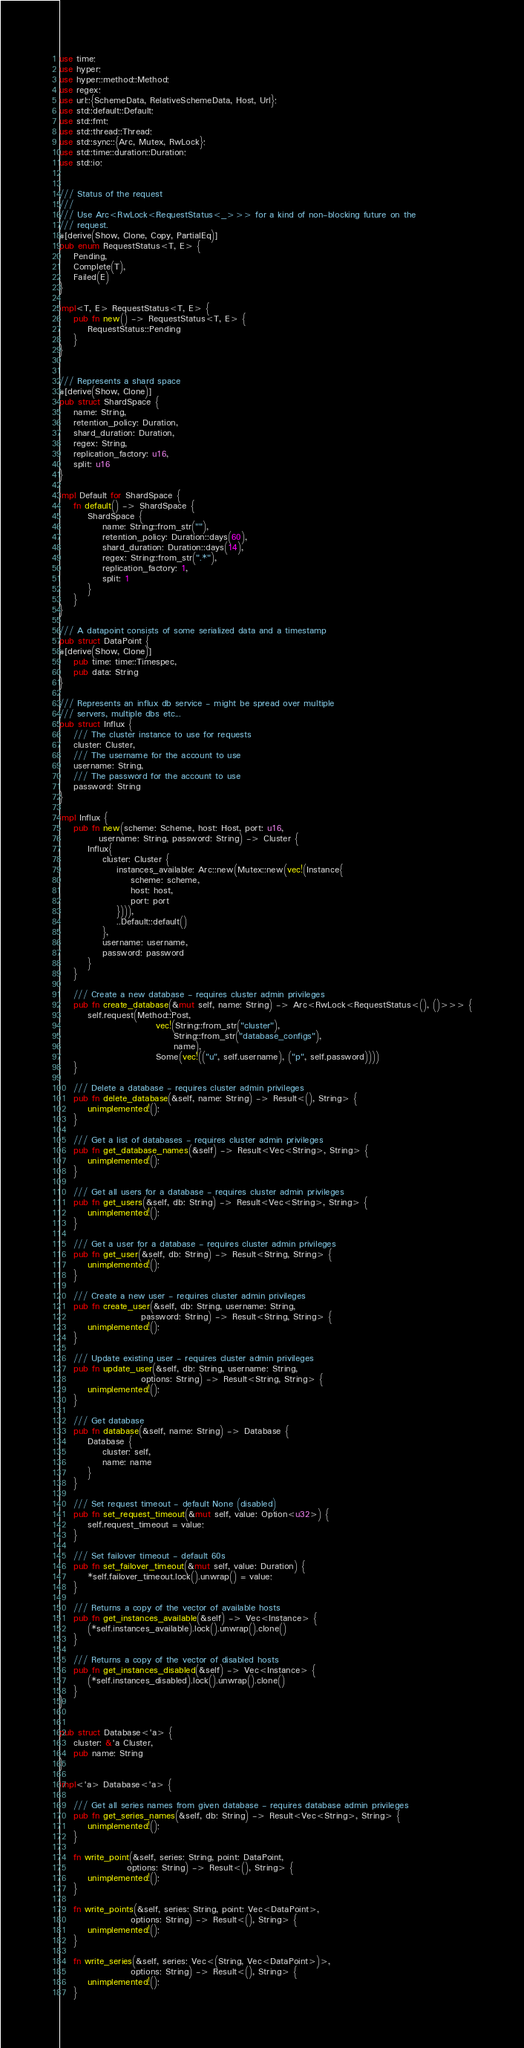Convert code to text. <code><loc_0><loc_0><loc_500><loc_500><_Rust_>use time;
use hyper;
use hyper::method::Method;
use regex;
use url::{SchemeData, RelativeSchemeData, Host, Url};
use std::default::Default;
use std::fmt;
use std::thread::Thread;
use std::sync::{Arc, Mutex, RwLock};
use std::time::duration::Duration;
use std::io;


/// Status of the request
///
/// Use Arc<RwLock<RequestStatus<_>>> for a kind of non-blocking future on the
/// request.
#[derive(Show, Clone, Copy, PartialEq)]
pub enum RequestStatus<T, E> {
    Pending,
    Complete(T),
    Failed(E)
}

impl<T, E> RequestStatus<T, E> {
    pub fn new() -> RequestStatus<T, E> {
        RequestStatus::Pending
    }
}


/// Represents a shard space
#[derive(Show, Clone)]
pub struct ShardSpace {
    name: String,
    retention_policy: Duration,
    shard_duration: Duration,
    regex: String,
    replication_factory: u16,
    split: u16
}

impl Default for ShardSpace {
    fn default() -> ShardSpace {
        ShardSpace {
            name: String::from_str(""),
            retention_policy: Duration::days(60),
            shard_duration: Duration::days(14),
            regex: String::from_str(".*"),
            replication_factory: 1,
            split: 1
        }
    }
}

/// A datapoint consists of some serialized data and a timestamp
pub struct DataPoint {
#[derive(Show, Clone)]
    pub time: time::Timespec,
    pub data: String
}

/// Represents an influx db service - might be spread over multiple
/// servers, multiple dbs etc...
pub struct Influx {
    /// The cluster instance to use for requests
    cluster: Cluster,
    /// The username for the account to use
    username: String,
    /// The password for the account to use
    password: String
}

impl Influx {
    pub fn new(scheme: Scheme, host: Host, port: u16,
           username: String, password: String) -> Cluster {
        Influx{
            cluster: Cluster {
                instances_available: Arc::new(Mutex::new(vec!(Instance{
                    scheme: scheme,
                    host: host,
                    port: port
                }))),
                ..Default::default()
            },
            username: username,
            password: password
        }
    }

    /// Create a new database - requires cluster admin privileges
    pub fn create_database(&mut self, name: String) -> Arc<RwLock<RequestStatus<(), ()>>> {
        self.request(Method::Post,
                           vec!(String::from_str("cluster"),
                                String::from_str("database_configs"),
                                name),
                           Some(vec!(("u", self.username), ("p", self.password))))
    }

    /// Delete a database - requires cluster admin privileges
    pub fn delete_database(&self, name: String) -> Result<(), String> {
        unimplemented!();
    }

    /// Get a list of databases - requires cluster admin privileges
    pub fn get_database_names(&self) -> Result<Vec<String>, String> {
        unimplemented!();
    }

    /// Get all users for a database - requires cluster admin privileges
    pub fn get_users(&self, db: String) -> Result<Vec<String>, String> {
        unimplemented!();
    }

    /// Get a user for a database - requires cluster admin privileges
    pub fn get_user(&self, db: String) -> Result<String, String> {
        unimplemented!();
    }

    /// Create a new user - requires cluster admin privileges
    pub fn create_user(&self, db: String, username: String,
                       password: String) -> Result<String, String> {
        unimplemented!();
    }

    /// Update existing user - requires cluster admin privileges
    pub fn update_user(&self, db: String, username: String,
                       options: String) -> Result<String, String> {
        unimplemented!();
    }

    /// Get database
    pub fn database(&self, name: String) -> Database {
        Database {
            cluster: self,
            name: name
        }
    }

    /// Set request timeout - default None (disabled)
    pub fn set_request_timeout(&mut self, value: Option<u32>) {
        self.request_timeout = value;
    }

    /// Set failover timeout - default 60s
    pub fn set_failover_timeout(&mut self, value: Duration) {
        *self.failover_timeout.lock().unwrap() = value;
    }

    /// Returns a copy of the vector of available hosts
    pub fn get_instances_available(&self) -> Vec<Instance> {
        (*self.instances_available).lock().unwrap().clone()
    }

    /// Returns a copy of the vector of disabled hosts
    pub fn get_instances_disabled(&self) -> Vec<Instance> {
        (*self.instances_disabled).lock().unwrap().clone()
    }
}


pub struct Database<'a> {
    cluster: &'a Cluster,
    pub name: String
}

impl<'a> Database<'a> {

    /// Get all series names from given database - requires database admin privileges
    pub fn get_series_names(&self, db: String) -> Result<Vec<String>, String> {
        unimplemented!();
    }

    fn write_point(&self, series: String, point: DataPoint,
                   options: String) -> Result<(), String> {
        unimplemented!();
    }

    fn write_points(&self, series: String, point: Vec<DataPoint>,
                    options: String) -> Result<(), String> {
        unimplemented!();
    }

    fn write_series(&self, series: Vec<(String, Vec<DataPoint>)>,
                    options: String) -> Result<(), String> {
        unimplemented!();
    }
</code> 